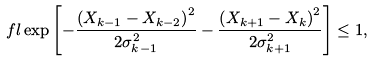Convert formula to latex. <formula><loc_0><loc_0><loc_500><loc_500>\ f l \exp \left [ - \frac { \left ( X _ { k - 1 } - X _ { k - 2 } \right ) ^ { 2 } } { 2 \sigma _ { k - 1 } ^ { 2 } } - \frac { \left ( X _ { k + 1 } - X _ { k } \right ) ^ { 2 } } { 2 \sigma _ { k + 1 } ^ { 2 } } \right ] \leq 1 ,</formula> 